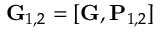<formula> <loc_0><loc_0><loc_500><loc_500>G _ { 1 , 2 } = [ G , P _ { 1 , 2 } ]</formula> 